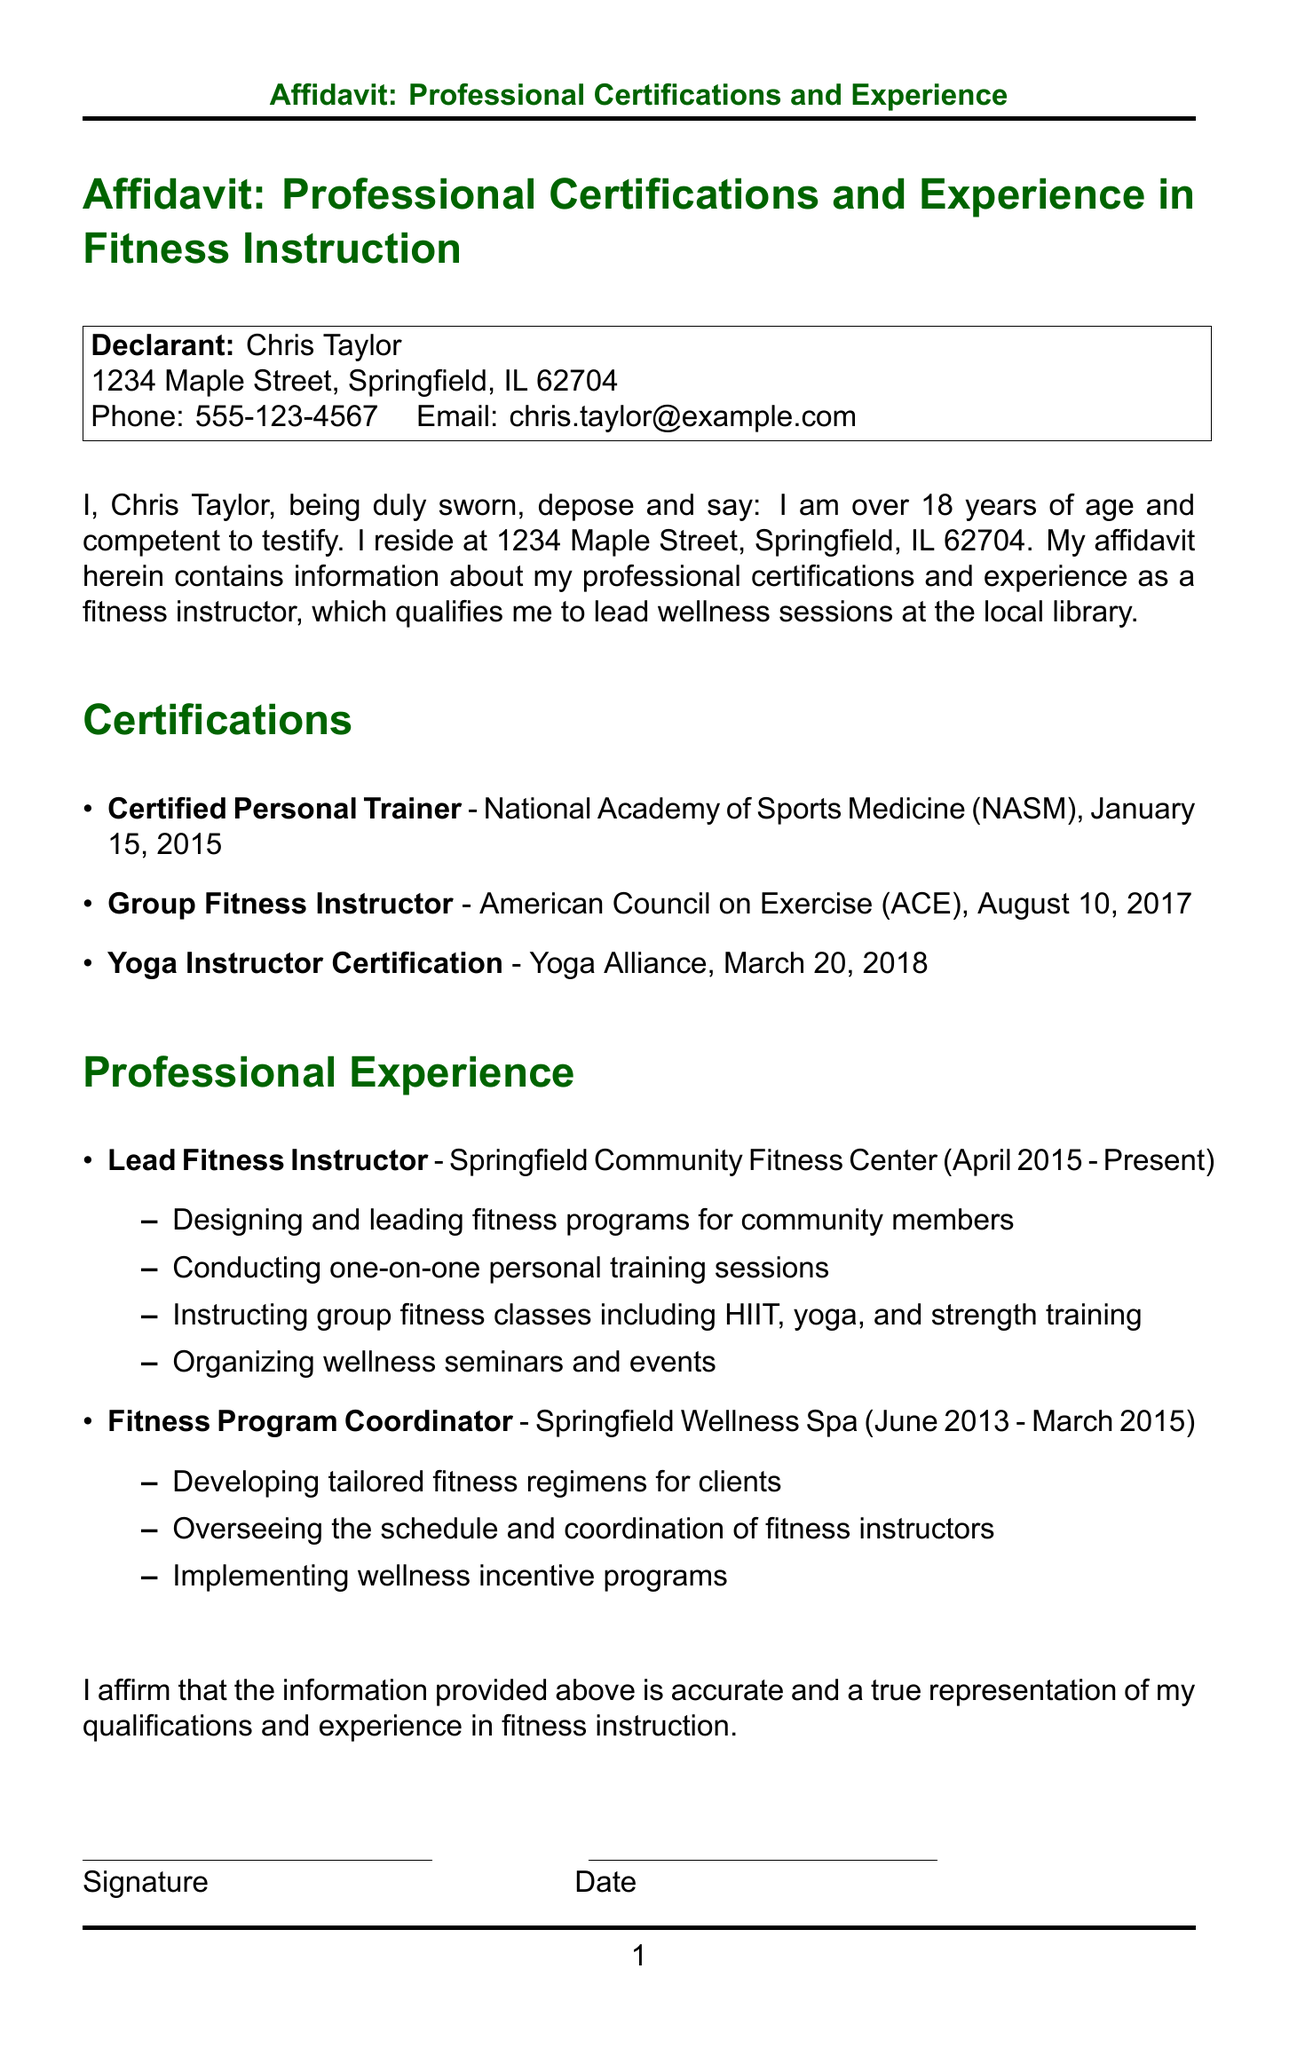what is the name of the declarant? The declarant is the individual who made the sworn statement, in this case, Chris Taylor.
Answer: Chris Taylor what is the address of the declarant? The address is where the declarant resides, which is listed in the document.
Answer: 1234 Maple Street, Springfield, IL 62704 what certification was obtained on January 15, 2015? This asks for the specific certification and its date as mentioned in the document.
Answer: Certified Personal Trainer what role did the declarant hold at the Springfield Community Fitness Center? This question seeks to identify the position of the declarant within the organization as stated in the document.
Answer: Lead Fitness Instructor how many years of experience does the declarant have as a fitness instructor? This requires reasoning about the dates provided in the professional experience section. The declarant's start date at the fitness center is April 2015, and the current date is assumed to be October 2023.
Answer: 8 years what organization provided the Yoga Instructor Certification? The question focuses on the specific organization that issued a certification mentioned in the document.
Answer: Yoga Alliance what are two types of fitness classes that the declarant instructs? This question asks for specific examples of the classes taught by the declarant based on the professional experience section.
Answer: HIIT, yoga what position did the declarant hold at Springfield Wellness Spa? This looks for the job title previously held at another organization as indicated in the professional experience section.
Answer: Fitness Program Coordinator who verifies the affidavit? This asks about the role of another individual in the documentation process.
Answer: Notary Public 